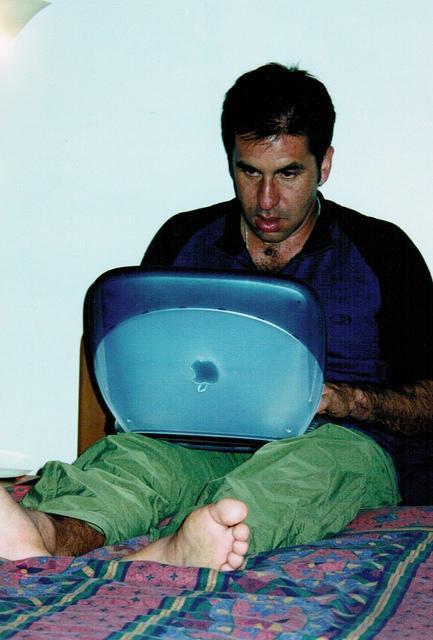How many toes are visible in this photo?
Give a very brief answer. 5. 